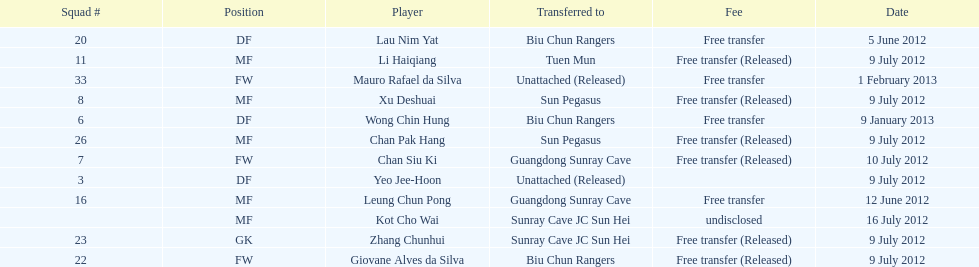What position is next to squad # 3? DF. 